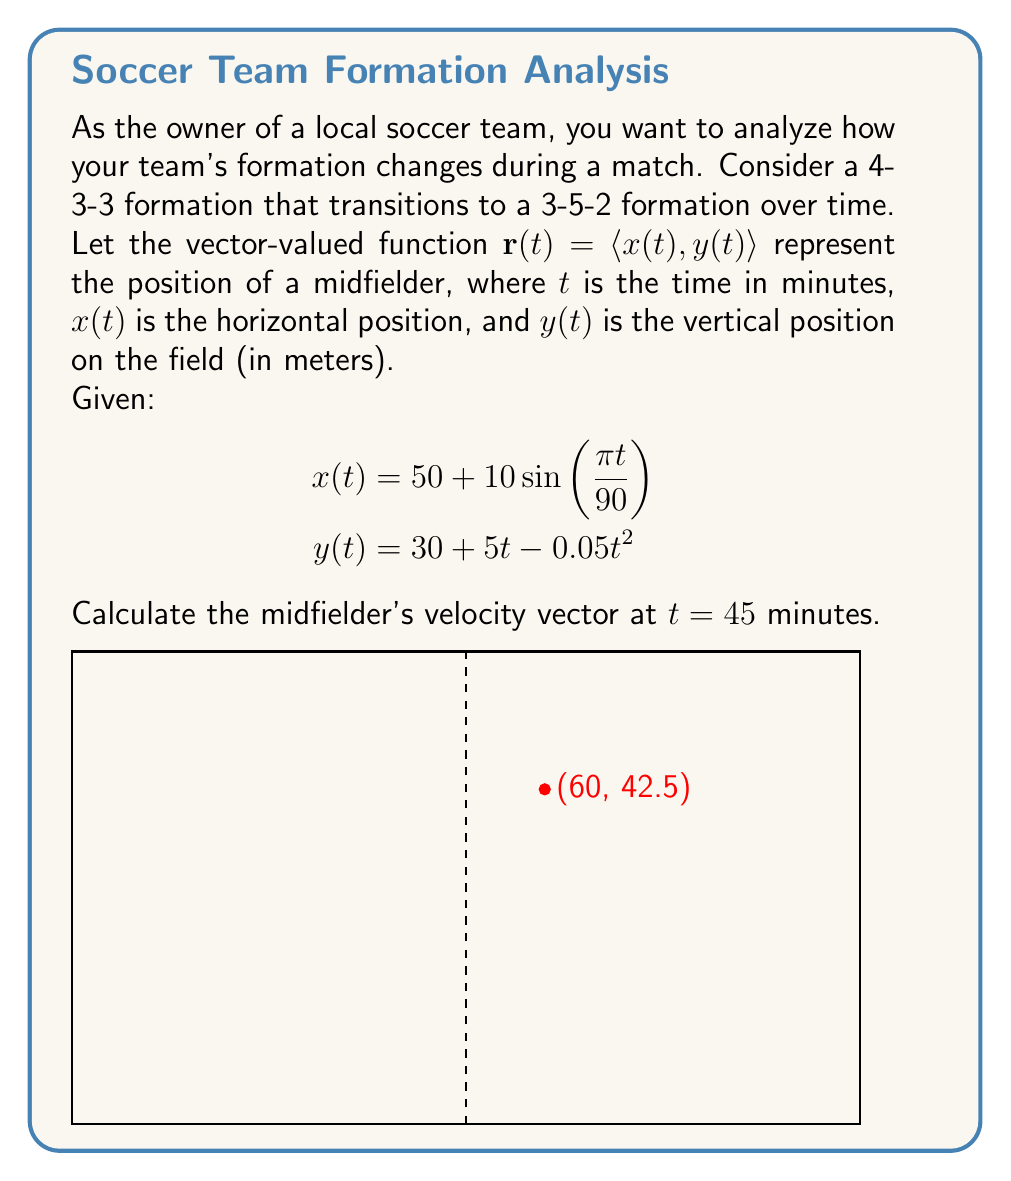Give your solution to this math problem. To find the velocity vector at $t = 45$ minutes, we need to calculate the derivative of the position vector $\mathbf{r}(t)$.

Step 1: Calculate $\frac{dx}{dt}$ and $\frac{dy}{dt}$

$\frac{dx}{dt} = 10 \cdot \frac{\pi}{90} \cos(\frac{\pi t}{90})$

$\frac{dy}{dt} = 5 - 0.1t$

Step 2: The velocity vector is given by $\mathbf{v}(t) = \langle \frac{dx}{dt}, \frac{dy}{dt} \rangle$

$\mathbf{v}(t) = \langle 10 \cdot \frac{\pi}{90} \cos(\frac{\pi t}{90}), 5 - 0.1t \rangle$

Step 3: Evaluate $\mathbf{v}(t)$ at $t = 45$

$\mathbf{v}(45) = \langle 10 \cdot \frac{\pi}{90} \cos(\frac{\pi \cdot 45}{90}), 5 - 0.1 \cdot 45 \rangle$

$\mathbf{v}(45) = \langle 10 \cdot \frac{\pi}{90} \cos(\frac{\pi}{2}), 5 - 4.5 \rangle$

$\mathbf{v}(45) = \langle 0, 0.5 \rangle$

Therefore, the midfielder's velocity vector at $t = 45$ minutes is $\langle 0, 0.5 \rangle$ meters per minute.
Answer: $\langle 0, 0.5 \rangle$ m/min 